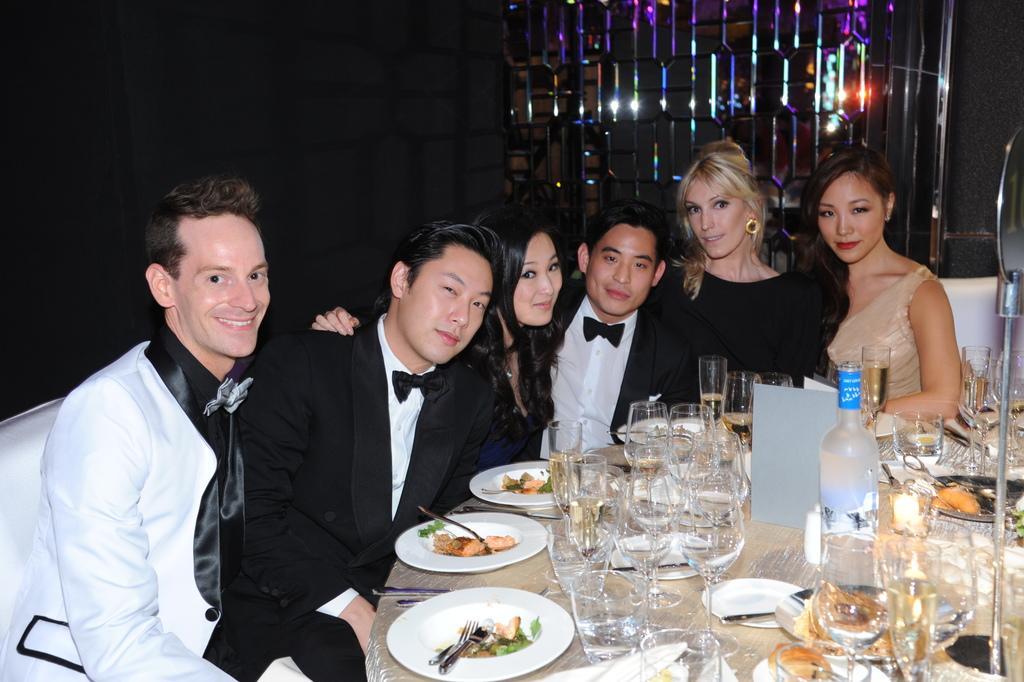Describe this image in one or two sentences. Here we can see three men and three women sitting at the table and on the table we can see food items in plates,wine bottle,glasses,spoons,forks and some other items. In the background there is a wall and a metal item. 